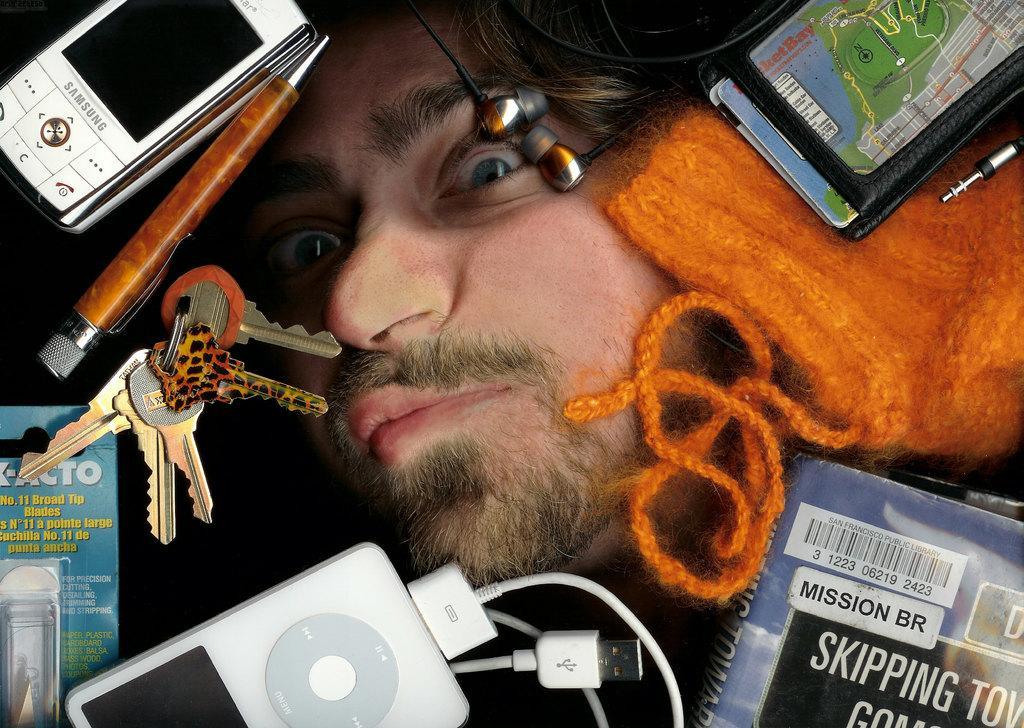How would you summarize this image in a sentence or two? In this picture we can see a person's face, mobile, pen, keys, device, cable, book, woolen cloth, earphones and an object. 